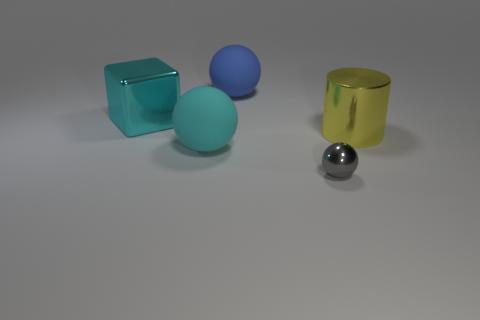Do the tiny gray sphere and the large cyan ball have the same material?
Your answer should be compact. No. Are there any large rubber objects that are behind the rubber sphere behind the big yellow object that is to the right of the cyan cube?
Ensure brevity in your answer.  No. What number of other objects are there of the same shape as the big blue thing?
Your answer should be very brief. 2. What is the shape of the object that is in front of the big cyan shiny cube and to the left of the tiny gray metallic ball?
Keep it short and to the point. Sphere. The rubber ball that is in front of the large matte thing that is behind the big thing in front of the big yellow metal object is what color?
Keep it short and to the point. Cyan. Are there more yellow cylinders that are left of the yellow shiny cylinder than shiny objects that are to the right of the blue thing?
Provide a short and direct response. No. What number of other objects are the same size as the cylinder?
Offer a very short reply. 3. What is the size of the matte ball that is the same color as the block?
Keep it short and to the point. Large. What material is the ball to the right of the matte object behind the large cyan cube?
Provide a short and direct response. Metal. Are there any matte balls to the left of the big cyan cube?
Provide a short and direct response. No. 